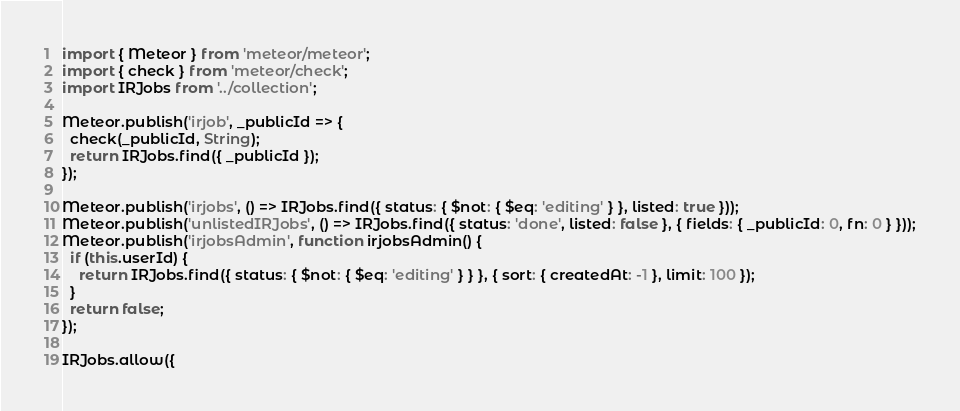Convert code to text. <code><loc_0><loc_0><loc_500><loc_500><_JavaScript_>import { Meteor } from 'meteor/meteor';
import { check } from 'meteor/check';
import IRJobs from '../collection';

Meteor.publish('irjob', _publicId => {
  check(_publicId, String);
  return IRJobs.find({ _publicId });
});

Meteor.publish('irjobs', () => IRJobs.find({ status: { $not: { $eq: 'editing' } }, listed: true }));
Meteor.publish('unlistedIRJobs', () => IRJobs.find({ status: 'done', listed: false }, { fields: { _publicId: 0, fn: 0 } }));
Meteor.publish('irjobsAdmin', function irjobsAdmin() {
  if (this.userId) {
    return IRJobs.find({ status: { $not: { $eq: 'editing' } } }, { sort: { createdAt: -1 }, limit: 100 });
  }
  return false;
});

IRJobs.allow({</code> 